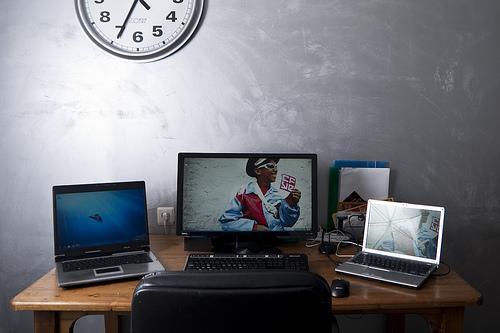How many computers are in this picture?
Give a very brief answer. 3. 